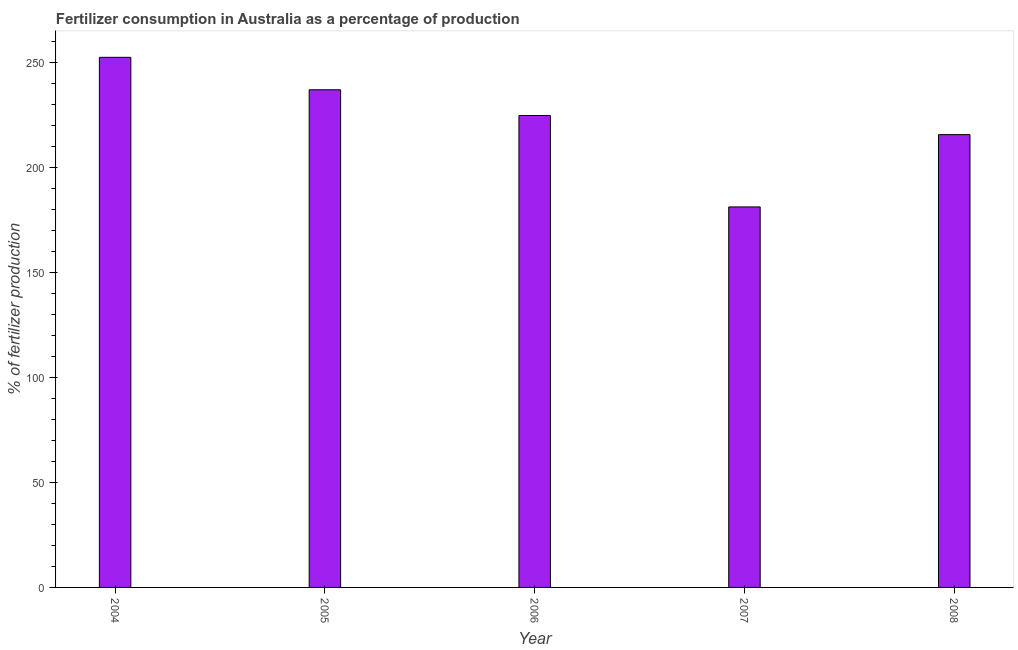Does the graph contain any zero values?
Your answer should be compact. No. What is the title of the graph?
Keep it short and to the point. Fertilizer consumption in Australia as a percentage of production. What is the label or title of the Y-axis?
Ensure brevity in your answer.  % of fertilizer production. What is the amount of fertilizer consumption in 2006?
Give a very brief answer. 224.65. Across all years, what is the maximum amount of fertilizer consumption?
Your answer should be compact. 252.35. Across all years, what is the minimum amount of fertilizer consumption?
Make the answer very short. 181.13. What is the sum of the amount of fertilizer consumption?
Make the answer very short. 1110.59. What is the difference between the amount of fertilizer consumption in 2004 and 2006?
Your response must be concise. 27.69. What is the average amount of fertilizer consumption per year?
Your answer should be very brief. 222.12. What is the median amount of fertilizer consumption?
Your answer should be compact. 224.65. In how many years, is the amount of fertilizer consumption greater than 230 %?
Keep it short and to the point. 2. Do a majority of the years between 2004 and 2005 (inclusive) have amount of fertilizer consumption greater than 80 %?
Your response must be concise. Yes. What is the ratio of the amount of fertilizer consumption in 2004 to that in 2006?
Your response must be concise. 1.12. Is the difference between the amount of fertilizer consumption in 2005 and 2007 greater than the difference between any two years?
Provide a short and direct response. No. What is the difference between the highest and the second highest amount of fertilizer consumption?
Give a very brief answer. 15.44. Is the sum of the amount of fertilizer consumption in 2005 and 2006 greater than the maximum amount of fertilizer consumption across all years?
Offer a very short reply. Yes. What is the difference between the highest and the lowest amount of fertilizer consumption?
Provide a short and direct response. 71.21. How many bars are there?
Ensure brevity in your answer.  5. Are all the bars in the graph horizontal?
Your response must be concise. No. How many years are there in the graph?
Your answer should be compact. 5. What is the % of fertilizer production of 2004?
Your response must be concise. 252.35. What is the % of fertilizer production in 2005?
Provide a short and direct response. 236.9. What is the % of fertilizer production in 2006?
Your response must be concise. 224.65. What is the % of fertilizer production of 2007?
Provide a short and direct response. 181.13. What is the % of fertilizer production in 2008?
Provide a succinct answer. 215.56. What is the difference between the % of fertilizer production in 2004 and 2005?
Keep it short and to the point. 15.44. What is the difference between the % of fertilizer production in 2004 and 2006?
Your answer should be very brief. 27.69. What is the difference between the % of fertilizer production in 2004 and 2007?
Your answer should be compact. 71.21. What is the difference between the % of fertilizer production in 2004 and 2008?
Offer a terse response. 36.79. What is the difference between the % of fertilizer production in 2005 and 2006?
Provide a succinct answer. 12.25. What is the difference between the % of fertilizer production in 2005 and 2007?
Offer a very short reply. 55.77. What is the difference between the % of fertilizer production in 2005 and 2008?
Ensure brevity in your answer.  21.35. What is the difference between the % of fertilizer production in 2006 and 2007?
Provide a succinct answer. 43.52. What is the difference between the % of fertilizer production in 2006 and 2008?
Your response must be concise. 9.1. What is the difference between the % of fertilizer production in 2007 and 2008?
Your answer should be compact. -34.42. What is the ratio of the % of fertilizer production in 2004 to that in 2005?
Your response must be concise. 1.06. What is the ratio of the % of fertilizer production in 2004 to that in 2006?
Give a very brief answer. 1.12. What is the ratio of the % of fertilizer production in 2004 to that in 2007?
Offer a very short reply. 1.39. What is the ratio of the % of fertilizer production in 2004 to that in 2008?
Make the answer very short. 1.17. What is the ratio of the % of fertilizer production in 2005 to that in 2006?
Your answer should be very brief. 1.05. What is the ratio of the % of fertilizer production in 2005 to that in 2007?
Make the answer very short. 1.31. What is the ratio of the % of fertilizer production in 2005 to that in 2008?
Offer a terse response. 1.1. What is the ratio of the % of fertilizer production in 2006 to that in 2007?
Keep it short and to the point. 1.24. What is the ratio of the % of fertilizer production in 2006 to that in 2008?
Provide a succinct answer. 1.04. What is the ratio of the % of fertilizer production in 2007 to that in 2008?
Provide a succinct answer. 0.84. 